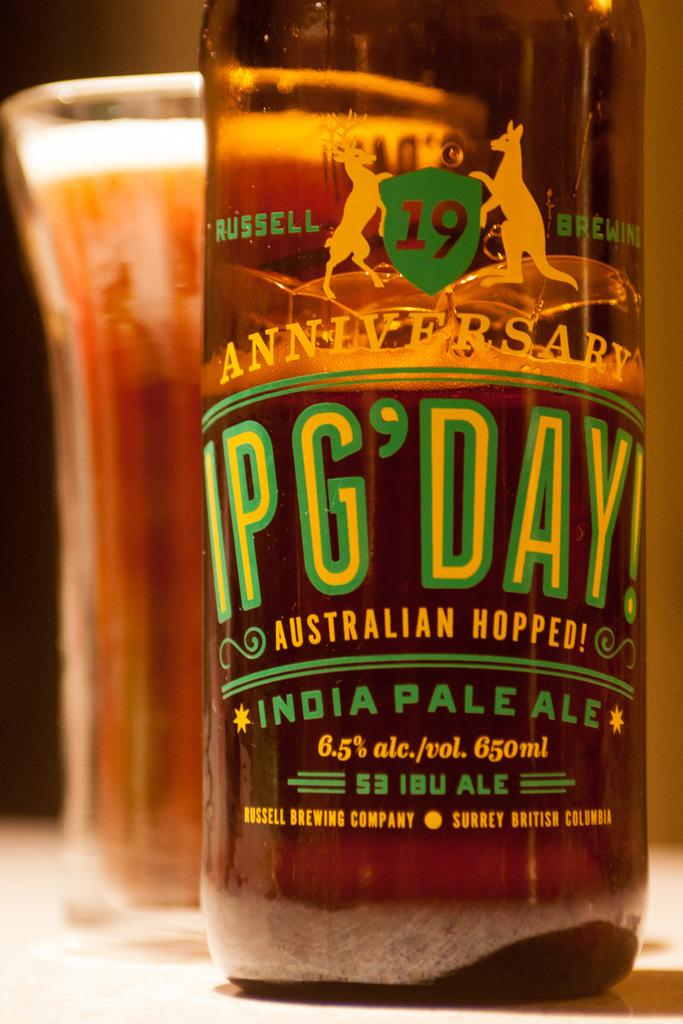<image>
Share a concise interpretation of the image provided. A bottle of India Pale Ale sits on a table. 